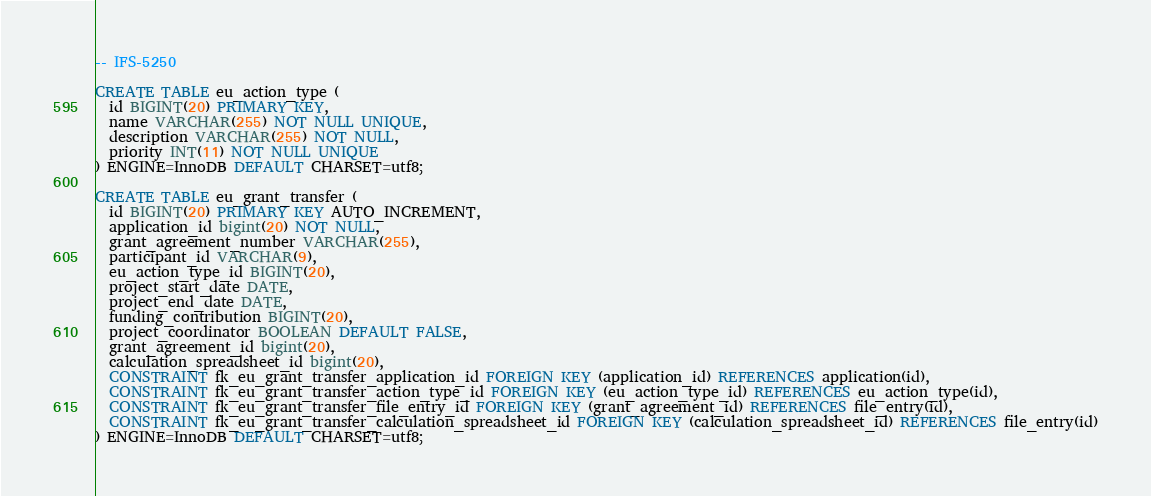Convert code to text. <code><loc_0><loc_0><loc_500><loc_500><_SQL_>-- IFS-5250

CREATE TABLE eu_action_type (
  id BIGINT(20) PRIMARY KEY,
  name VARCHAR(255) NOT NULL UNIQUE,
  description VARCHAR(255) NOT NULL,
  priority INT(11) NOT NULL UNIQUE
) ENGINE=InnoDB DEFAULT CHARSET=utf8;

CREATE TABLE eu_grant_transfer (
  id BIGINT(20) PRIMARY KEY AUTO_INCREMENT,
  application_id bigint(20) NOT NULL,
  grant_agreement_number VARCHAR(255),
  participant_id VARCHAR(9),
  eu_action_type_id BIGINT(20),
  project_start_date DATE,
  project_end_date DATE,
  funding_contribution BIGINT(20),
  project_coordinator BOOLEAN DEFAULT FALSE,
  grant_agreement_id bigint(20),
  calculation_spreadsheet_id bigint(20),
  CONSTRAINT fk_eu_grant_transfer_application_id FOREIGN KEY (application_id) REFERENCES application(id),
  CONSTRAINT fk_eu_grant_transfer_action_type_id FOREIGN KEY (eu_action_type_id) REFERENCES eu_action_type(id),
  CONSTRAINT fk_eu_grant_transfer_file_entry_id FOREIGN KEY (grant_agreement_id) REFERENCES file_entry(id),
  CONSTRAINT fk_eu_grant_transfer_calculation_spreadsheet_id FOREIGN KEY (calculation_spreadsheet_id) REFERENCES file_entry(id)
) ENGINE=InnoDB DEFAULT CHARSET=utf8;
</code> 